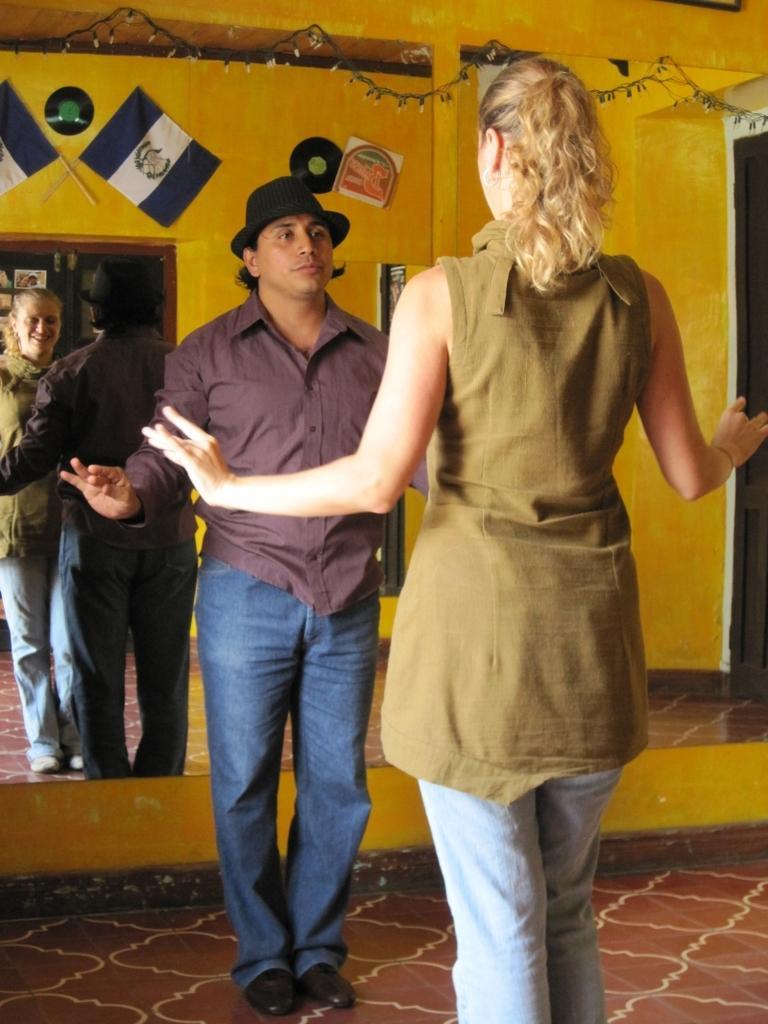In one or two sentences, can you explain what this image depicts? In this image in the foreground there is one man and one woman standing, and in the background there is a mirror and through the mirror we could see reflection of man and a woman and also there are some flags and some discs on the wall. On the right side there is a door, and at the top of the image there are lights. At the bottom there is floor. 